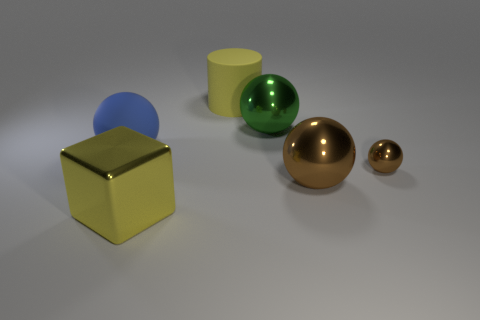Add 2 large blue balls. How many objects exist? 8 Subtract all metal balls. How many balls are left? 1 Subtract 1 cylinders. How many cylinders are left? 0 Subtract all green cubes. Subtract all green cylinders. How many cubes are left? 1 Subtract all yellow blocks. How many gray balls are left? 0 Subtract all large yellow cylinders. Subtract all blue rubber things. How many objects are left? 4 Add 3 big green shiny things. How many big green shiny things are left? 4 Add 1 large green metallic objects. How many large green metallic objects exist? 2 Subtract all brown balls. How many balls are left? 2 Subtract 2 brown balls. How many objects are left? 4 